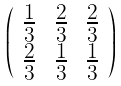<formula> <loc_0><loc_0><loc_500><loc_500>\left ( \begin{array} { c c c } \frac { 1 } { 3 } & \frac { 2 } { 3 } & \frac { 2 } { 3 } \\ \frac { 2 } { 3 } & \frac { 1 } { 3 } & \frac { 1 } { 3 } \end{array} \right )</formula> 